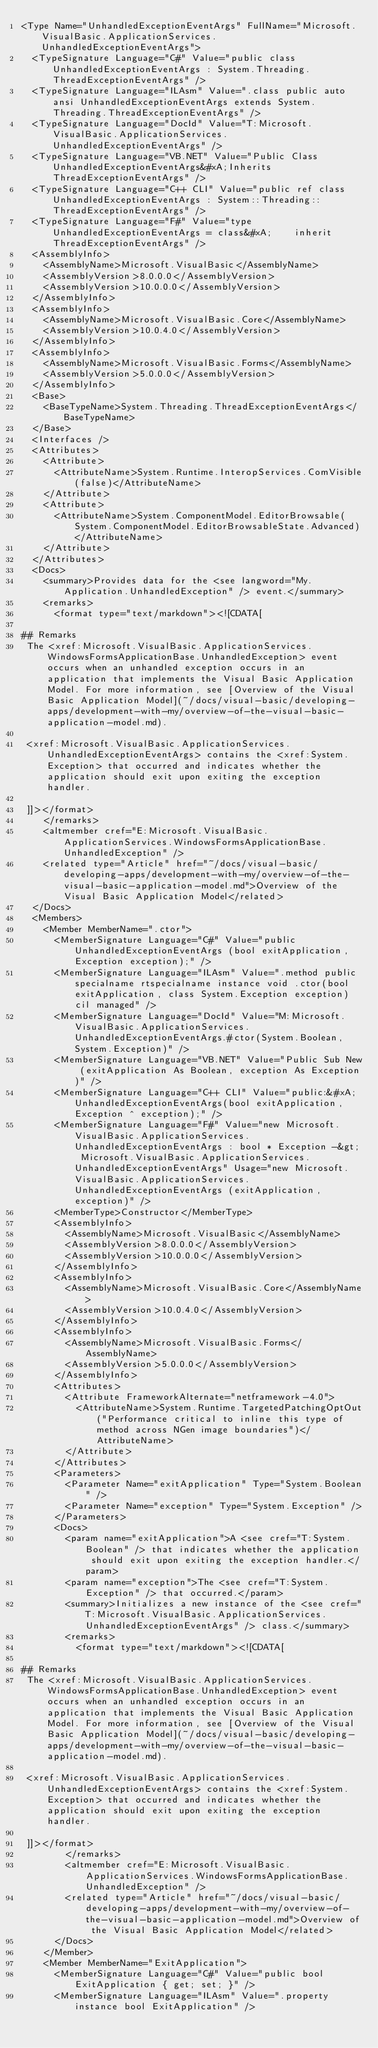Convert code to text. <code><loc_0><loc_0><loc_500><loc_500><_XML_><Type Name="UnhandledExceptionEventArgs" FullName="Microsoft.VisualBasic.ApplicationServices.UnhandledExceptionEventArgs">
  <TypeSignature Language="C#" Value="public class UnhandledExceptionEventArgs : System.Threading.ThreadExceptionEventArgs" />
  <TypeSignature Language="ILAsm" Value=".class public auto ansi UnhandledExceptionEventArgs extends System.Threading.ThreadExceptionEventArgs" />
  <TypeSignature Language="DocId" Value="T:Microsoft.VisualBasic.ApplicationServices.UnhandledExceptionEventArgs" />
  <TypeSignature Language="VB.NET" Value="Public Class UnhandledExceptionEventArgs&#xA;Inherits ThreadExceptionEventArgs" />
  <TypeSignature Language="C++ CLI" Value="public ref class UnhandledExceptionEventArgs : System::Threading::ThreadExceptionEventArgs" />
  <TypeSignature Language="F#" Value="type UnhandledExceptionEventArgs = class&#xA;    inherit ThreadExceptionEventArgs" />
  <AssemblyInfo>
    <AssemblyName>Microsoft.VisualBasic</AssemblyName>
    <AssemblyVersion>8.0.0.0</AssemblyVersion>
    <AssemblyVersion>10.0.0.0</AssemblyVersion>
  </AssemblyInfo>
  <AssemblyInfo>
    <AssemblyName>Microsoft.VisualBasic.Core</AssemblyName>
    <AssemblyVersion>10.0.4.0</AssemblyVersion>
  </AssemblyInfo>
  <AssemblyInfo>
    <AssemblyName>Microsoft.VisualBasic.Forms</AssemblyName>
    <AssemblyVersion>5.0.0.0</AssemblyVersion>
  </AssemblyInfo>
  <Base>
    <BaseTypeName>System.Threading.ThreadExceptionEventArgs</BaseTypeName>
  </Base>
  <Interfaces />
  <Attributes>
    <Attribute>
      <AttributeName>System.Runtime.InteropServices.ComVisible(false)</AttributeName>
    </Attribute>
    <Attribute>
      <AttributeName>System.ComponentModel.EditorBrowsable(System.ComponentModel.EditorBrowsableState.Advanced)</AttributeName>
    </Attribute>
  </Attributes>
  <Docs>
    <summary>Provides data for the <see langword="My.Application.UnhandledException" /> event.</summary>
    <remarks>
      <format type="text/markdown"><![CDATA[  
  
## Remarks  
 The <xref:Microsoft.VisualBasic.ApplicationServices.WindowsFormsApplicationBase.UnhandledException> event occurs when an unhandled exception occurs in an application that implements the Visual Basic Application Model. For more information, see [Overview of the Visual Basic Application Model](~/docs/visual-basic/developing-apps/development-with-my/overview-of-the-visual-basic-application-model.md).  
  
 <xref:Microsoft.VisualBasic.ApplicationServices.UnhandledExceptionEventArgs> contains the <xref:System.Exception> that occurred and indicates whether the application should exit upon exiting the exception handler.  
  
 ]]></format>
    </remarks>
    <altmember cref="E:Microsoft.VisualBasic.ApplicationServices.WindowsFormsApplicationBase.UnhandledException" />
    <related type="Article" href="~/docs/visual-basic/developing-apps/development-with-my/overview-of-the-visual-basic-application-model.md">Overview of the Visual Basic Application Model</related>
  </Docs>
  <Members>
    <Member MemberName=".ctor">
      <MemberSignature Language="C#" Value="public UnhandledExceptionEventArgs (bool exitApplication, Exception exception);" />
      <MemberSignature Language="ILAsm" Value=".method public specialname rtspecialname instance void .ctor(bool exitApplication, class System.Exception exception) cil managed" />
      <MemberSignature Language="DocId" Value="M:Microsoft.VisualBasic.ApplicationServices.UnhandledExceptionEventArgs.#ctor(System.Boolean,System.Exception)" />
      <MemberSignature Language="VB.NET" Value="Public Sub New (exitApplication As Boolean, exception As Exception)" />
      <MemberSignature Language="C++ CLI" Value="public:&#xA; UnhandledExceptionEventArgs(bool exitApplication, Exception ^ exception);" />
      <MemberSignature Language="F#" Value="new Microsoft.VisualBasic.ApplicationServices.UnhandledExceptionEventArgs : bool * Exception -&gt; Microsoft.VisualBasic.ApplicationServices.UnhandledExceptionEventArgs" Usage="new Microsoft.VisualBasic.ApplicationServices.UnhandledExceptionEventArgs (exitApplication, exception)" />
      <MemberType>Constructor</MemberType>
      <AssemblyInfo>
        <AssemblyName>Microsoft.VisualBasic</AssemblyName>
        <AssemblyVersion>8.0.0.0</AssemblyVersion>
        <AssemblyVersion>10.0.0.0</AssemblyVersion>
      </AssemblyInfo>
      <AssemblyInfo>
        <AssemblyName>Microsoft.VisualBasic.Core</AssemblyName>
        <AssemblyVersion>10.0.4.0</AssemblyVersion>
      </AssemblyInfo>
      <AssemblyInfo>
        <AssemblyName>Microsoft.VisualBasic.Forms</AssemblyName>
        <AssemblyVersion>5.0.0.0</AssemblyVersion>
      </AssemblyInfo>
      <Attributes>
        <Attribute FrameworkAlternate="netframework-4.0">
          <AttributeName>System.Runtime.TargetedPatchingOptOut("Performance critical to inline this type of method across NGen image boundaries")</AttributeName>
        </Attribute>
      </Attributes>
      <Parameters>
        <Parameter Name="exitApplication" Type="System.Boolean" />
        <Parameter Name="exception" Type="System.Exception" />
      </Parameters>
      <Docs>
        <param name="exitApplication">A <see cref="T:System.Boolean" /> that indicates whether the application should exit upon exiting the exception handler.</param>
        <param name="exception">The <see cref="T:System.Exception" /> that occurred.</param>
        <summary>Initializes a new instance of the <see cref="T:Microsoft.VisualBasic.ApplicationServices.UnhandledExceptionEventArgs" /> class.</summary>
        <remarks>
          <format type="text/markdown"><![CDATA[  
  
## Remarks  
 The <xref:Microsoft.VisualBasic.ApplicationServices.WindowsFormsApplicationBase.UnhandledException> event occurs when an unhandled exception occurs in an application that implements the Visual Basic Application Model. For more information, see [Overview of the Visual Basic Application Model](~/docs/visual-basic/developing-apps/development-with-my/overview-of-the-visual-basic-application-model.md).  
  
 <xref:Microsoft.VisualBasic.ApplicationServices.UnhandledExceptionEventArgs> contains the <xref:System.Exception> that occurred and indicates whether the application should exit upon exiting the exception handler.  
  
 ]]></format>
        </remarks>
        <altmember cref="E:Microsoft.VisualBasic.ApplicationServices.WindowsFormsApplicationBase.UnhandledException" />
        <related type="Article" href="~/docs/visual-basic/developing-apps/development-with-my/overview-of-the-visual-basic-application-model.md">Overview of the Visual Basic Application Model</related>
      </Docs>
    </Member>
    <Member MemberName="ExitApplication">
      <MemberSignature Language="C#" Value="public bool ExitApplication { get; set; }" />
      <MemberSignature Language="ILAsm" Value=".property instance bool ExitApplication" /></code> 